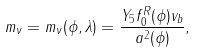<formula> <loc_0><loc_0><loc_500><loc_500>m _ { \nu } = m _ { \nu } ( \phi , \lambda ) = \frac { Y _ { 5 } f _ { 0 } ^ { R } ( \phi ) v _ { b } } { a ^ { 2 } ( \phi ) } ,</formula> 